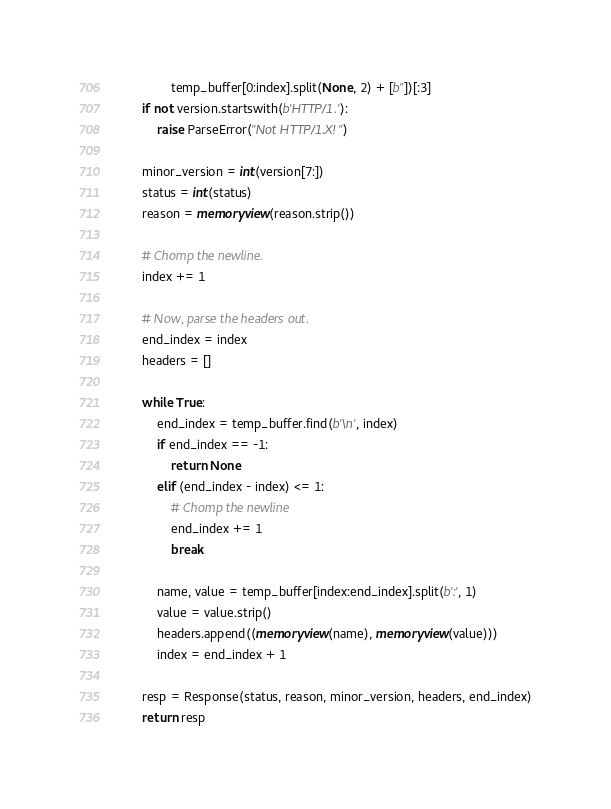Convert code to text. <code><loc_0><loc_0><loc_500><loc_500><_Python_>                temp_buffer[0:index].split(None, 2) + [b''])[:3]
        if not version.startswith(b'HTTP/1.'):
            raise ParseError("Not HTTP/1.X!")

        minor_version = int(version[7:])
        status = int(status)
        reason = memoryview(reason.strip())

        # Chomp the newline.
        index += 1

        # Now, parse the headers out.
        end_index = index
        headers = []

        while True:
            end_index = temp_buffer.find(b'\n', index)
            if end_index == -1:
                return None
            elif (end_index - index) <= 1:
                # Chomp the newline
                end_index += 1
                break

            name, value = temp_buffer[index:end_index].split(b':', 1)
            value = value.strip()
            headers.append((memoryview(name), memoryview(value)))
            index = end_index + 1

        resp = Response(status, reason, minor_version, headers, end_index)
        return resp
</code> 